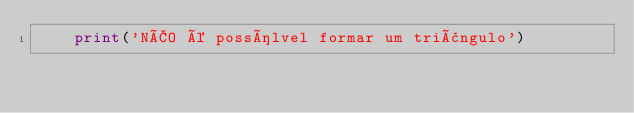Convert code to text. <code><loc_0><loc_0><loc_500><loc_500><_Python_>    print('NÃO é possílvel formar um triângulo')
</code> 